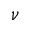Convert formula to latex. <formula><loc_0><loc_0><loc_500><loc_500>\nu</formula> 